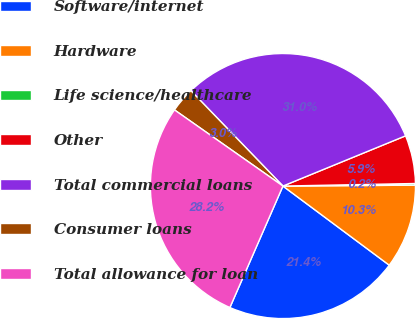Convert chart. <chart><loc_0><loc_0><loc_500><loc_500><pie_chart><fcel>Software/internet<fcel>Hardware<fcel>Life science/healthcare<fcel>Other<fcel>Total commercial loans<fcel>Consumer loans<fcel>Total allowance for loan<nl><fcel>21.37%<fcel>10.29%<fcel>0.2%<fcel>5.88%<fcel>31.03%<fcel>3.04%<fcel>28.19%<nl></chart> 